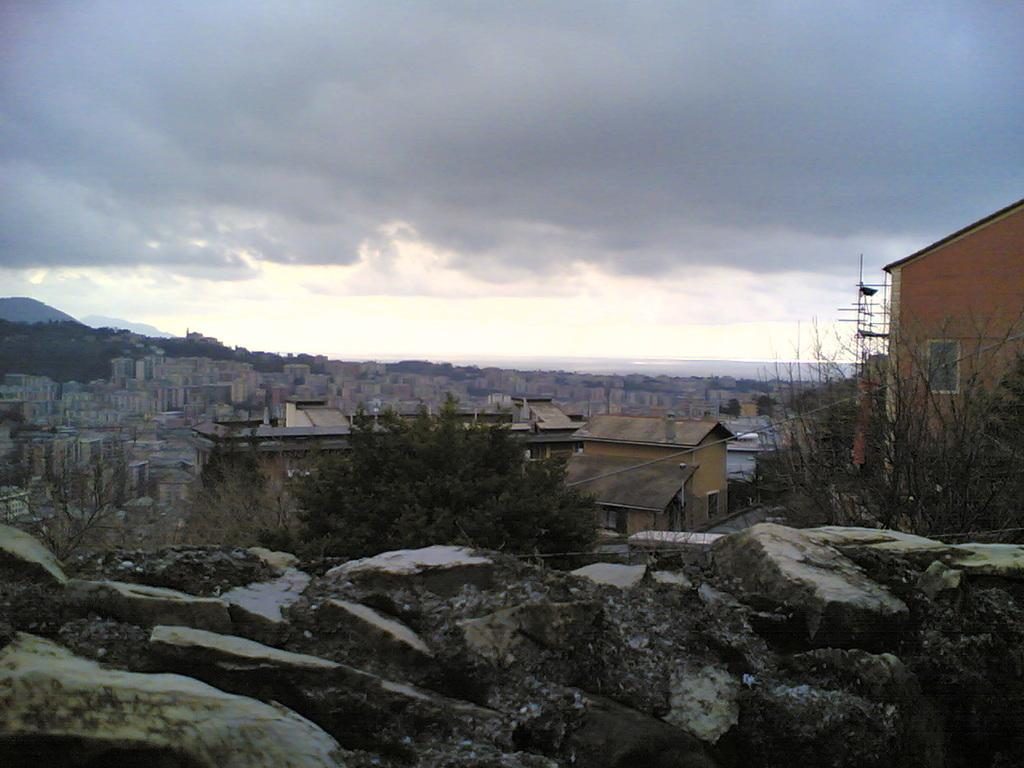What type of view is shown in the image? The image has an outside view. What can be seen in the middle of the image? There are buildings in the middle of the image. What is located beside the rocks in the image? There is a tree beside the rocks. What is visible in the background of the image? The sky is visible in the background of the image. What type of badge is hanging from the tree in the image? There is no badge present in the image; it features a tree beside rocks. What flavor of cub can be seen in the image? There is no cub or mention of flavor in the image; it shows an outside view with buildings, a tree, rocks, and the sky. 